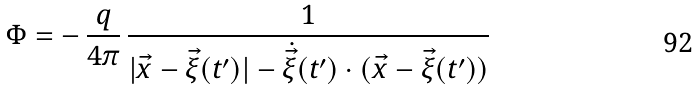<formula> <loc_0><loc_0><loc_500><loc_500>\Phi = - \, \frac { q } { 4 \pi } \, \frac { 1 } { | \vec { x } - \vec { \xi } ( t ^ { \prime } ) | - \dot { \vec { \xi } } ( { t ^ { \prime } } ) \cdot ( \vec { x } - \vec { \xi } ( t ^ { \prime } ) ) }</formula> 